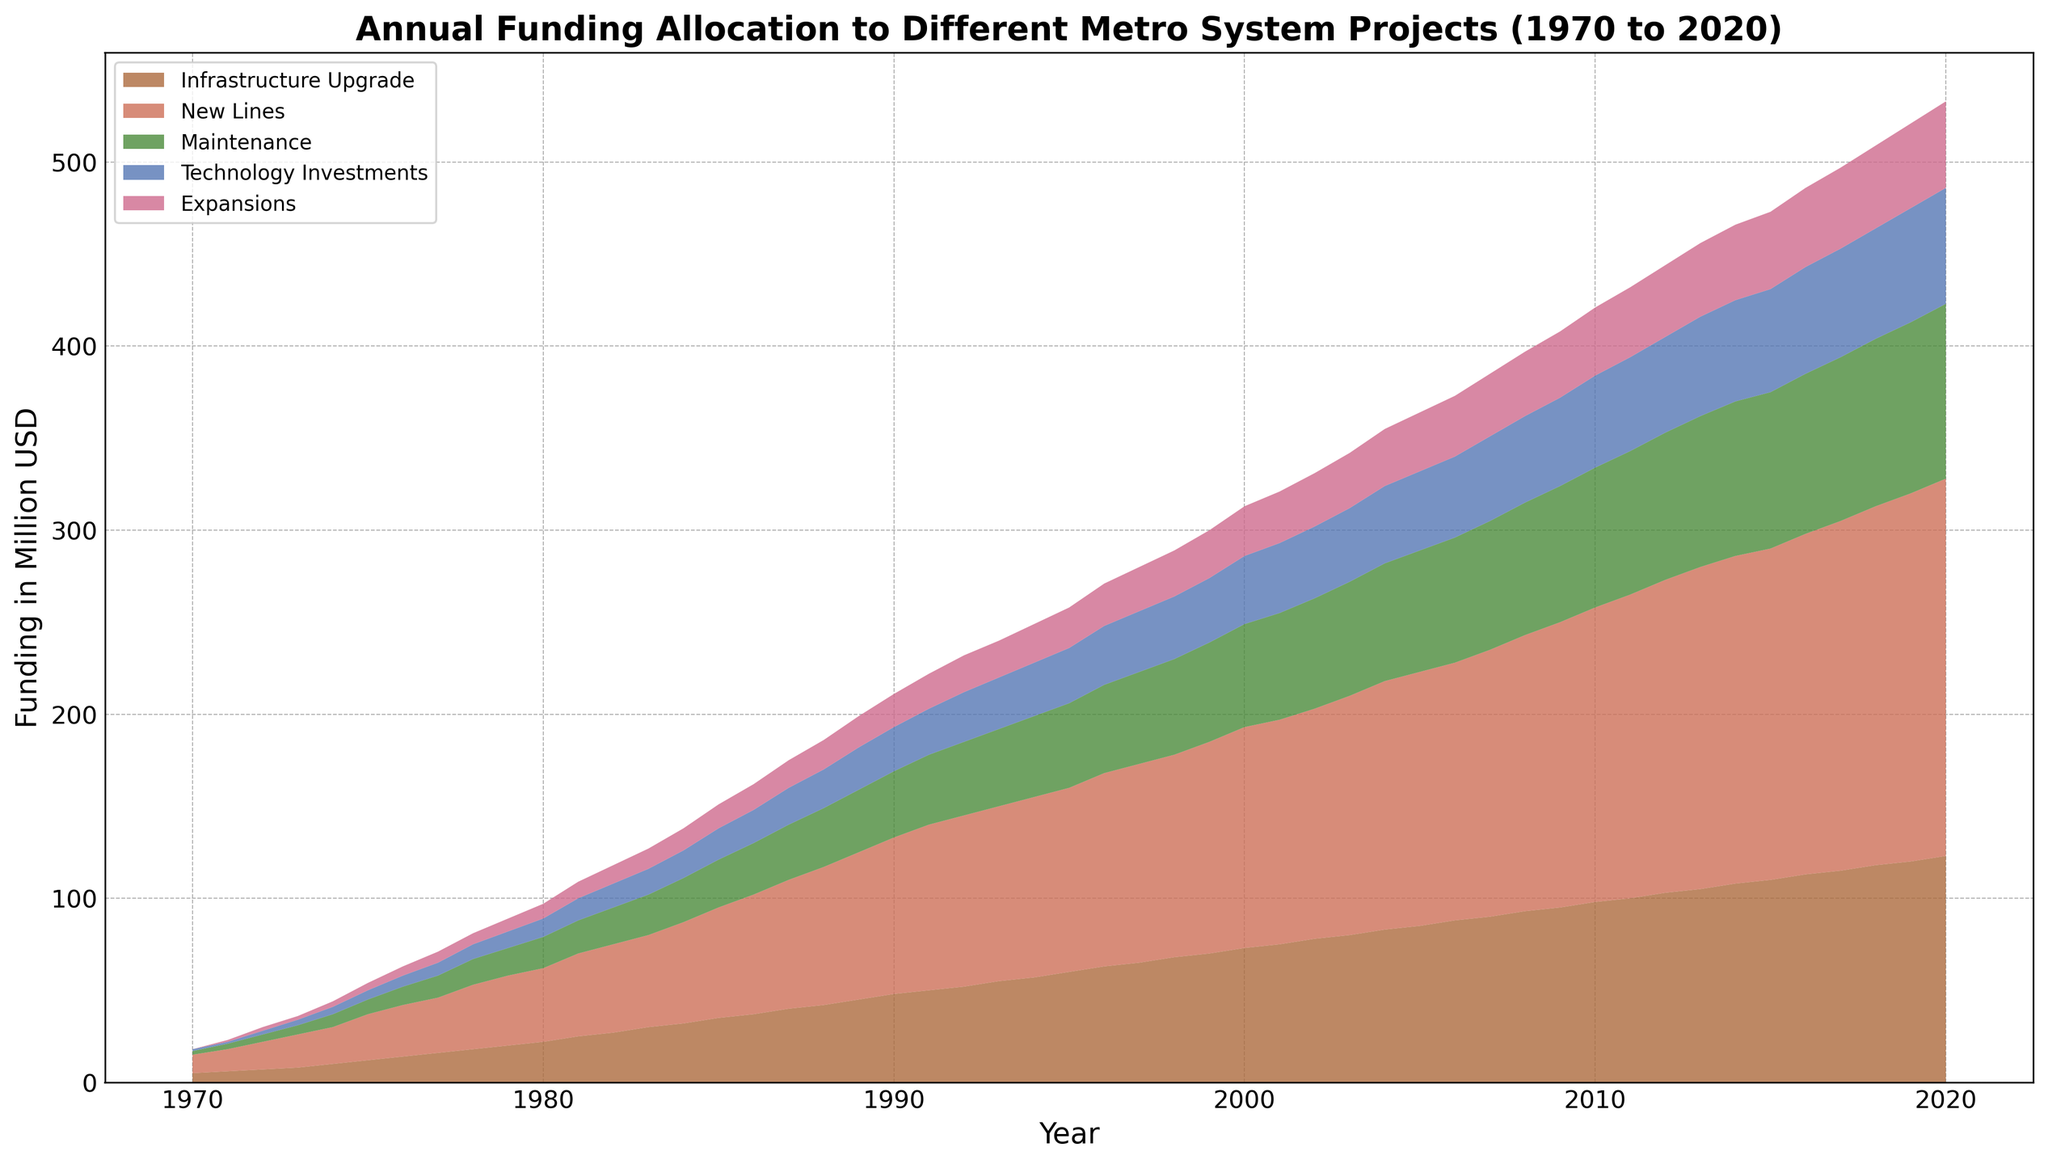What is the total funding allocation to Technology Investments in 2020? In the figure, find the data point for Technology Investments in 2020.
Answer: 63 Which year saw the highest funding for New Lines? Identify the year in the figure where the 'New Lines' section attains its maximum height.
Answer: 2020 By how much did the funding for Maintenance increase from 1970 to 1980? Compare the data points for Maintenance in 1970 and 1980. Subtract the value in 1970 from the value in 1980.
Answer: 15 What is the difference in funding between Infrastructure Upgrade and Expansions in 2010? Locate the values for Infrastructure Upgrade and Expansions in 2010 on the figure. Subtract the value for Expansions from the value for Infrastructure Upgrade.
Answer: 61 Which category received the least funding in 1975? Compare the heights of the different sections in the year 1975, looking for the smallest one.
Answer: Expansions Between which years did Technology Investments see the most significant jump in funding? Observe the changes in the height of the Technology Investments section year by year, finding the largest increase.
Answer: 1974-1975 If you sum the funding for Infrastructure Upgrade and Maintenance in 1990, what is the total? Find and sum the values for Infrastructure Upgrade and Maintenance in 1990 from the figure.
Answer: 84 How does the funding for Expansions in 2000 compare to 2010? Look at the 'Expansions' data points in 2000 and 2010 and observe if one is greater than the other.
Answer: Greater in 2010 By what percentage did the New Lines funding increase from 1970 to 1995? Determine the values for New Lines in 1970 and 1995. Use the formula ((Later Value - Earlier Value) / Earlier Value) * 100 to find the percentage increase.
Answer: 900% What are the combined total funding allocations for all projects in the year 1984? Sum the values of all categories (Infrastructure Upgrade, New Lines, Maintenance, Technology Investments, Expansions) in 1984.
Answer: 138 